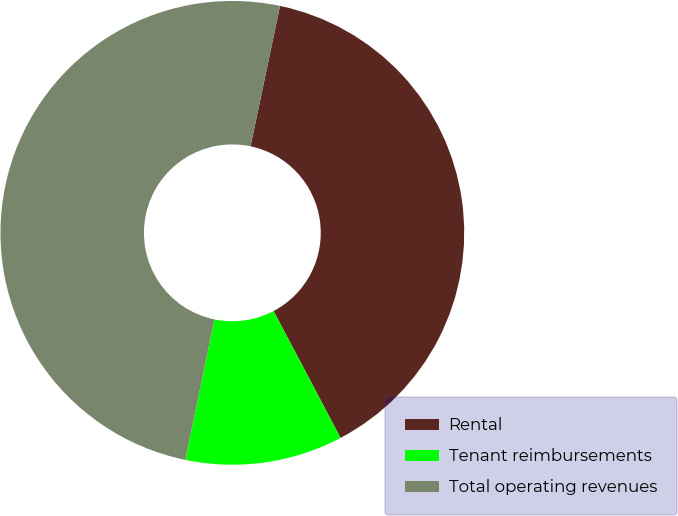<chart> <loc_0><loc_0><loc_500><loc_500><pie_chart><fcel>Rental<fcel>Tenant reimbursements<fcel>Total operating revenues<nl><fcel>38.98%<fcel>10.98%<fcel>50.05%<nl></chart> 